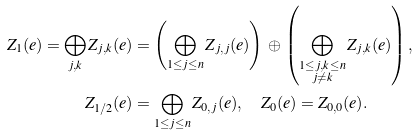<formula> <loc_0><loc_0><loc_500><loc_500>Z _ { 1 } ( e ) = \bigoplus _ { j , k } Z _ { j , k } ( { e } ) & = \left ( \bigoplus _ { 1 \leq j \leq n } Z _ { j , j } ( { e } ) \right ) \, \oplus \, \left ( \bigoplus _ { \substack { 1 \leq j , k \leq n \\ j \neq k } } Z _ { j , k } ( { e } ) \right ) , \\ Z _ { 1 / 2 } ( e ) & = \bigoplus _ { 1 \leq j \leq n } Z _ { 0 , j } ( { e } ) , \quad Z _ { 0 } ( { e } ) = Z _ { 0 , 0 } ( { e } ) .</formula> 